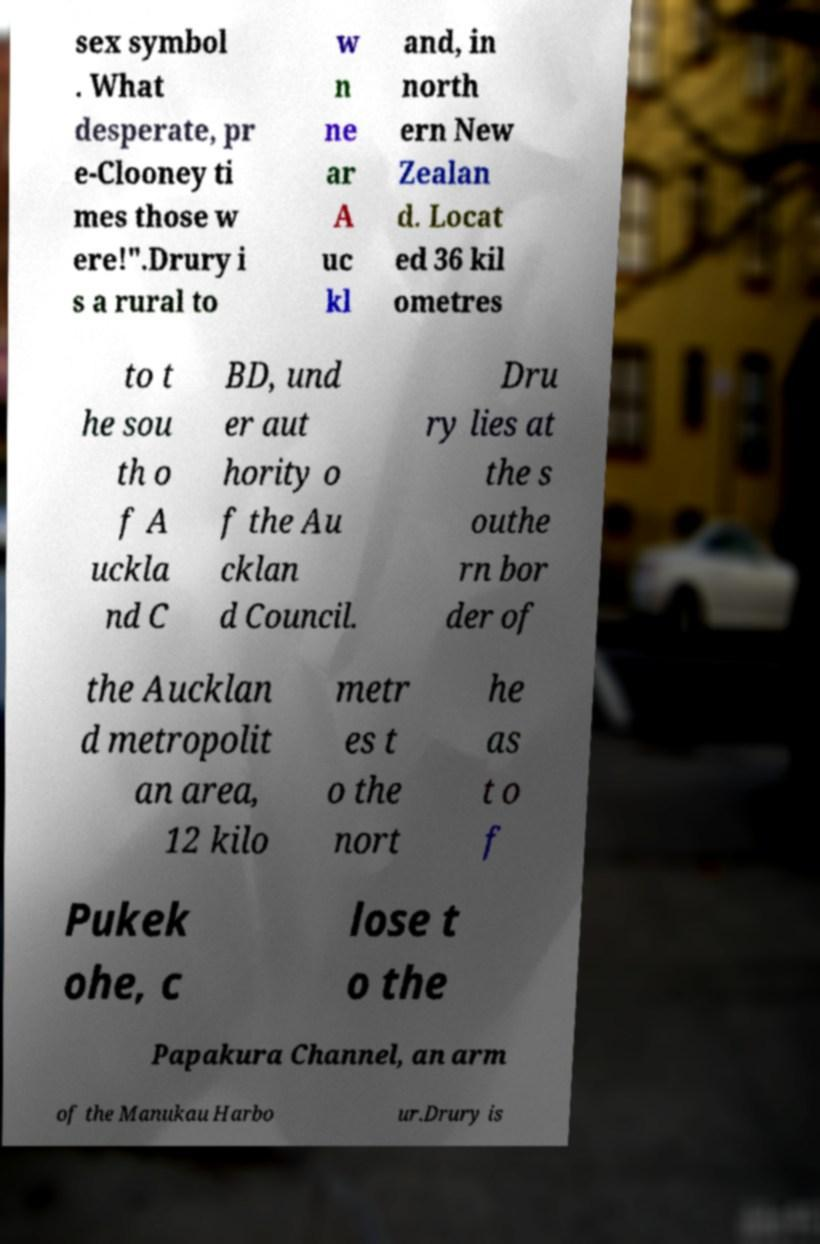There's text embedded in this image that I need extracted. Can you transcribe it verbatim? sex symbol . What desperate, pr e-Clooney ti mes those w ere!".Drury i s a rural to w n ne ar A uc kl and, in north ern New Zealan d. Locat ed 36 kil ometres to t he sou th o f A uckla nd C BD, und er aut hority o f the Au cklan d Council. Dru ry lies at the s outhe rn bor der of the Aucklan d metropolit an area, 12 kilo metr es t o the nort he as t o f Pukek ohe, c lose t o the Papakura Channel, an arm of the Manukau Harbo ur.Drury is 